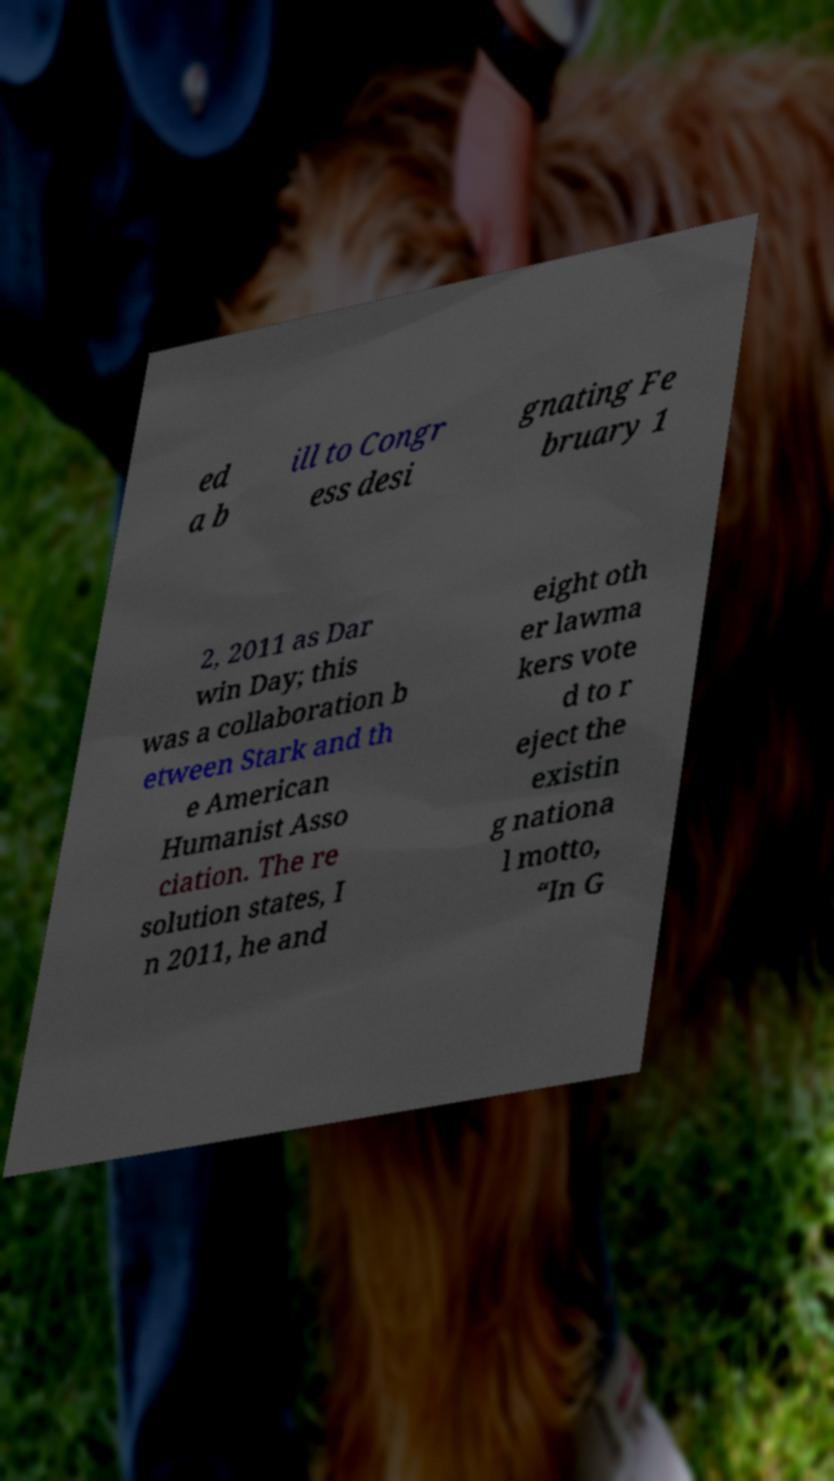For documentation purposes, I need the text within this image transcribed. Could you provide that? ed a b ill to Congr ess desi gnating Fe bruary 1 2, 2011 as Dar win Day; this was a collaboration b etween Stark and th e American Humanist Asso ciation. The re solution states, I n 2011, he and eight oth er lawma kers vote d to r eject the existin g nationa l motto, “In G 